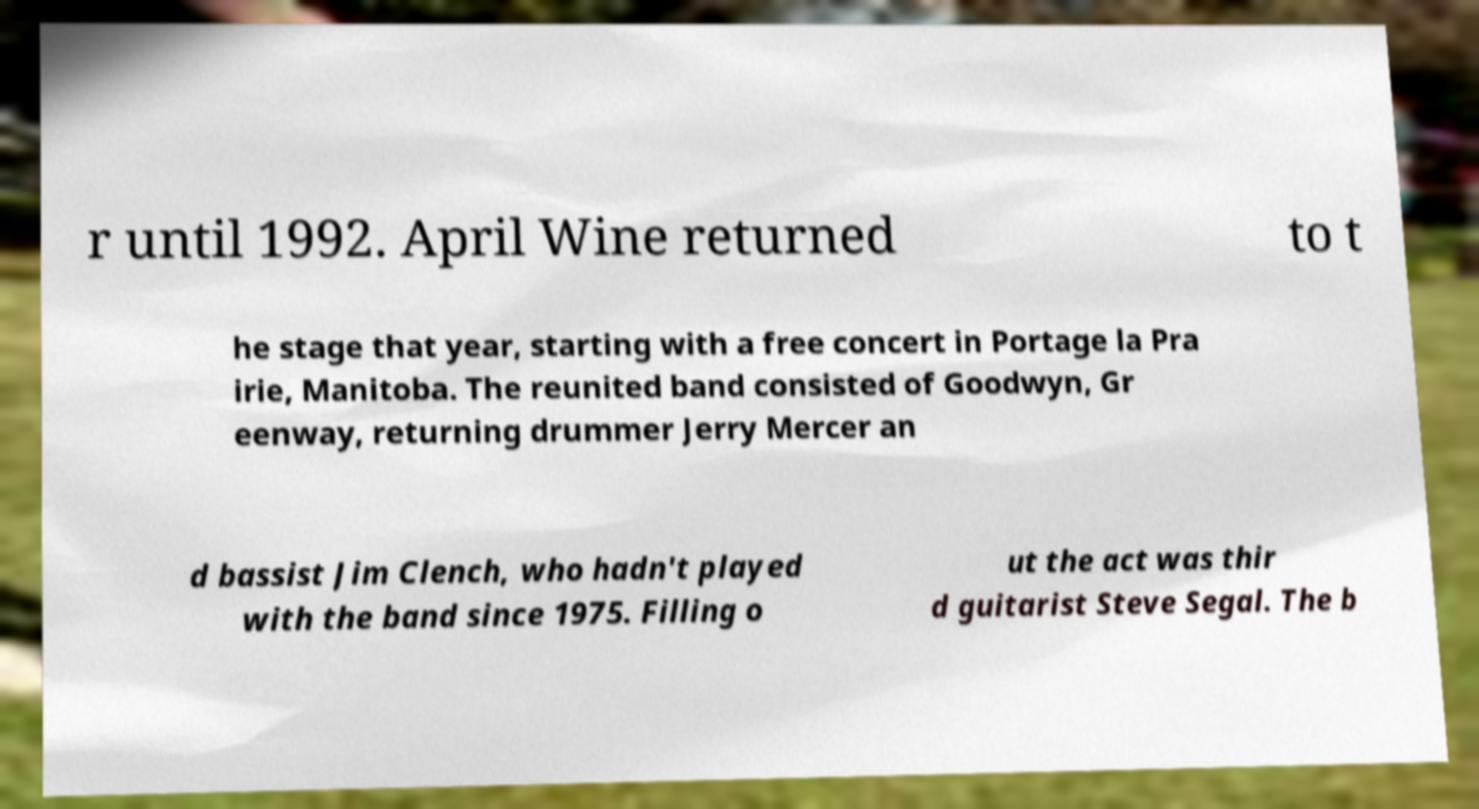Please identify and transcribe the text found in this image. r until 1992. April Wine returned to t he stage that year, starting with a free concert in Portage la Pra irie, Manitoba. The reunited band consisted of Goodwyn, Gr eenway, returning drummer Jerry Mercer an d bassist Jim Clench, who hadn't played with the band since 1975. Filling o ut the act was thir d guitarist Steve Segal. The b 